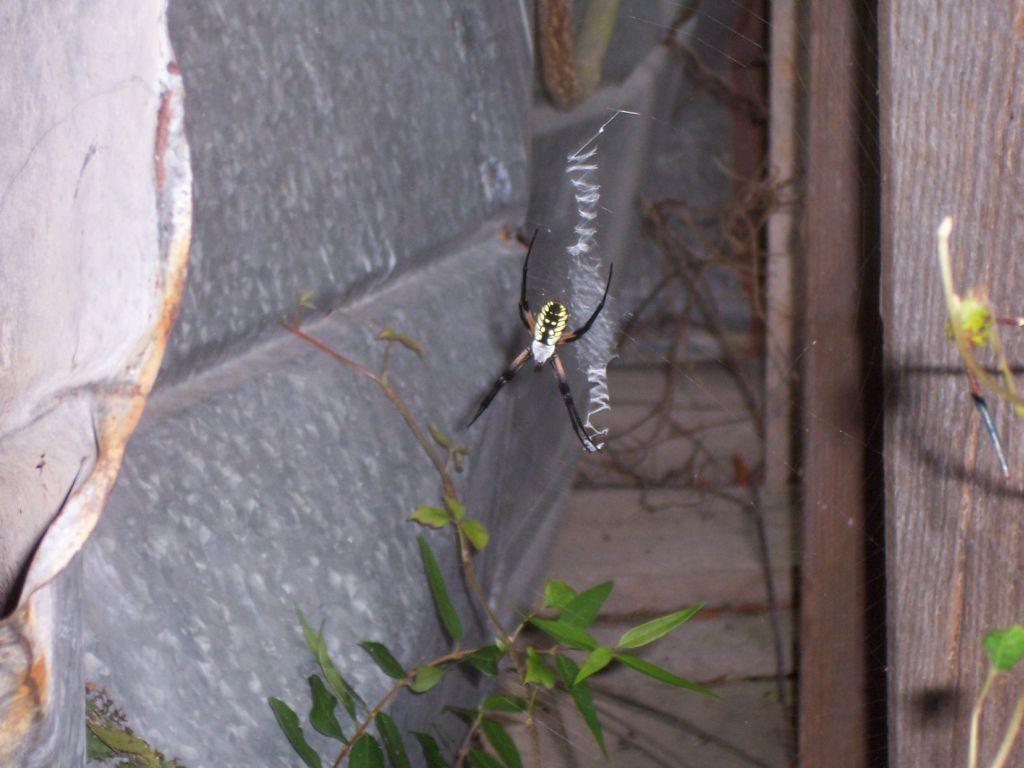Please provide a concise description of this image. In the middle there is a spider in the web, at the down there are leaves of a plant. 